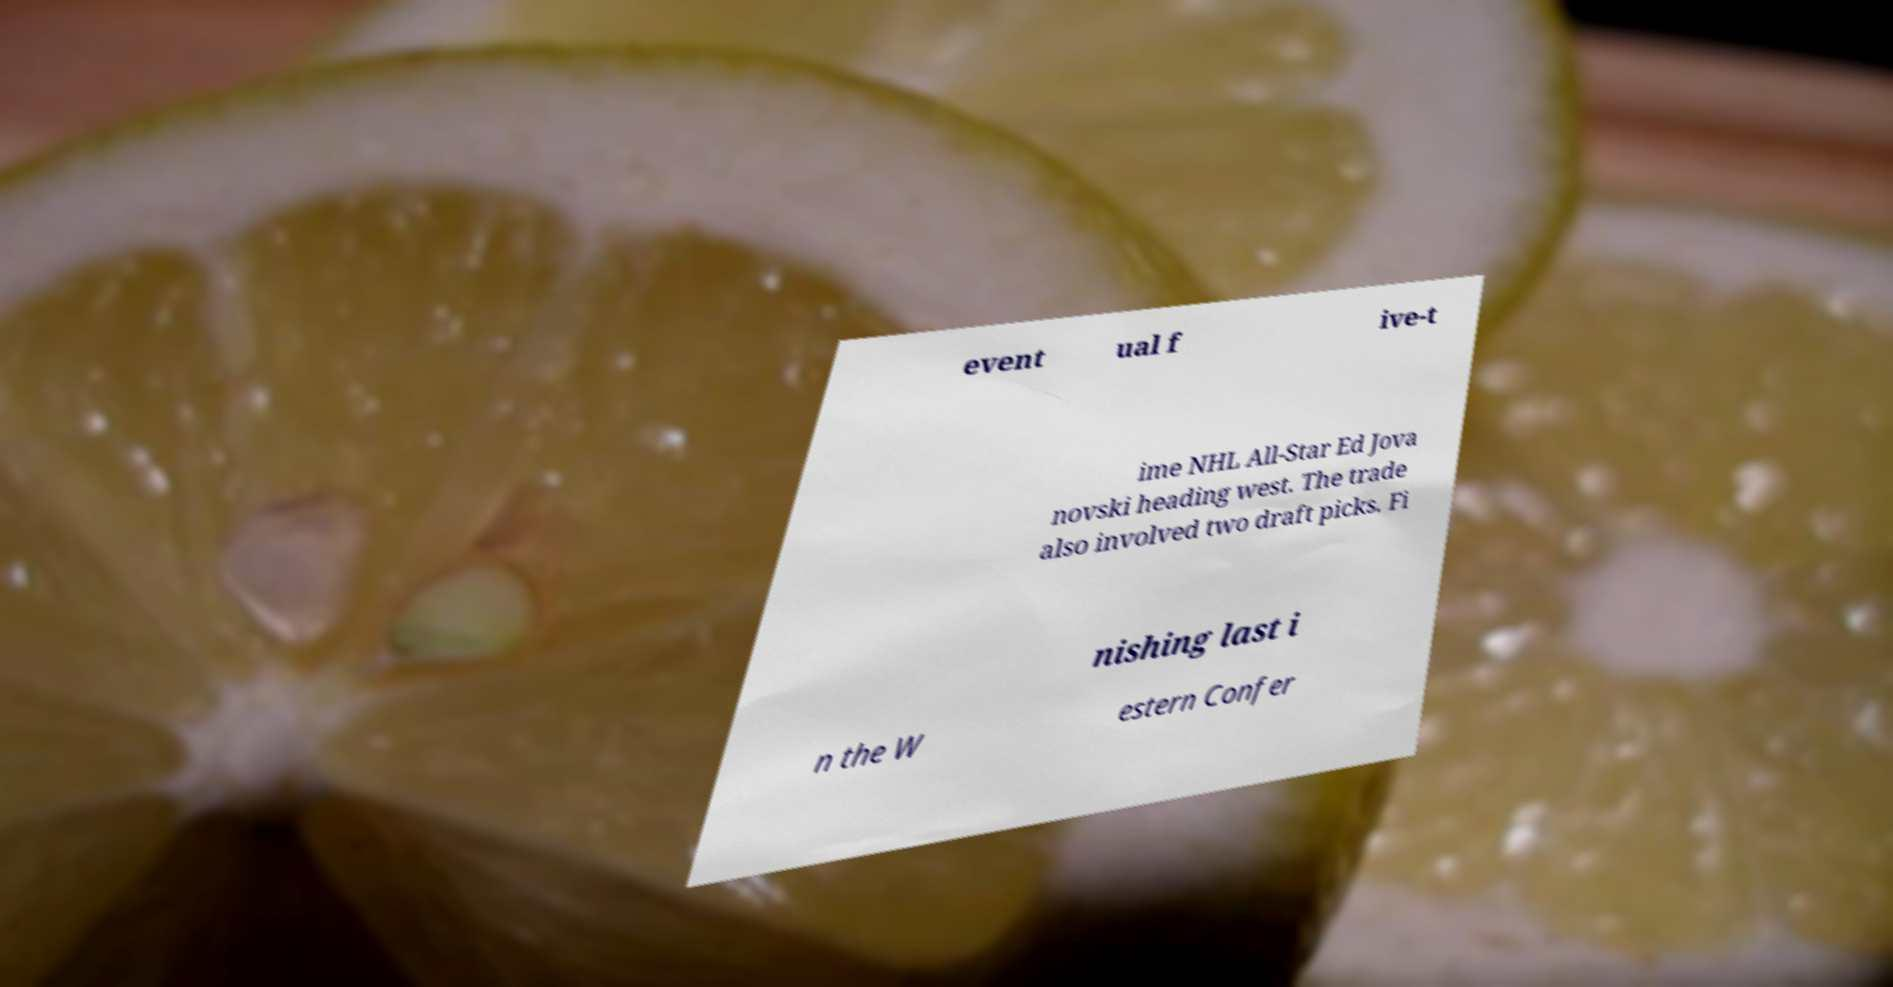Can you accurately transcribe the text from the provided image for me? event ual f ive-t ime NHL All-Star Ed Jova novski heading west. The trade also involved two draft picks. Fi nishing last i n the W estern Confer 